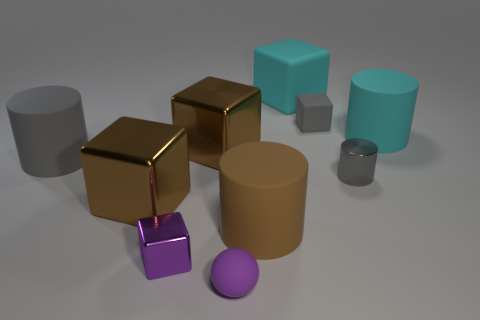There is a small cube to the left of the tiny purple sphere; is its color the same as the tiny ball?
Make the answer very short. Yes. Are there any big objects to the left of the big cylinder to the right of the small metallic thing that is right of the purple matte thing?
Provide a short and direct response. Yes. There is a shiny thing that is right of the cyan matte cube; is its size the same as the purple matte ball?
Make the answer very short. Yes. How many cyan rubber cubes are the same size as the brown cylinder?
Offer a very short reply. 1. What size is the other cylinder that is the same color as the metal cylinder?
Ensure brevity in your answer.  Large. Is the color of the tiny matte sphere the same as the tiny metallic block?
Keep it short and to the point. Yes. What shape is the purple shiny thing?
Offer a terse response. Cube. Is there a metal thing of the same color as the metal cylinder?
Offer a very short reply. No. Are there more gray rubber cylinders that are left of the big brown cylinder than brown matte balls?
Your response must be concise. Yes. There is a big brown matte thing; does it have the same shape as the small object behind the cyan rubber cylinder?
Ensure brevity in your answer.  No. 